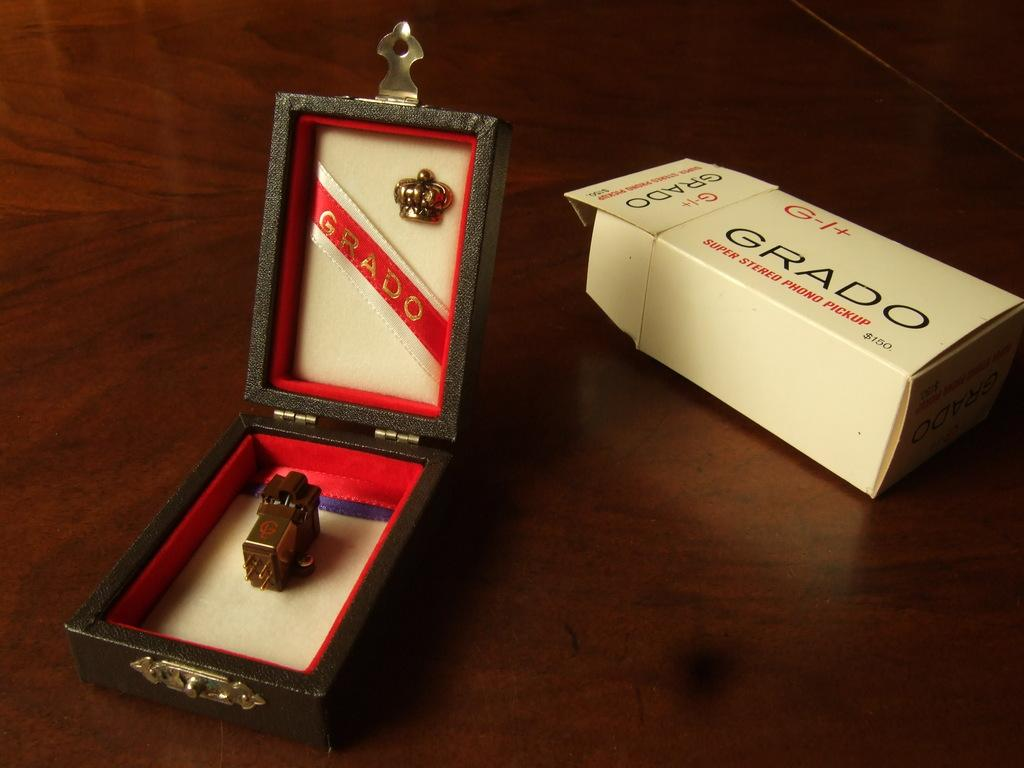<image>
Share a concise interpretation of the image provided. Small box with an object in it and the word Grado as the label. 